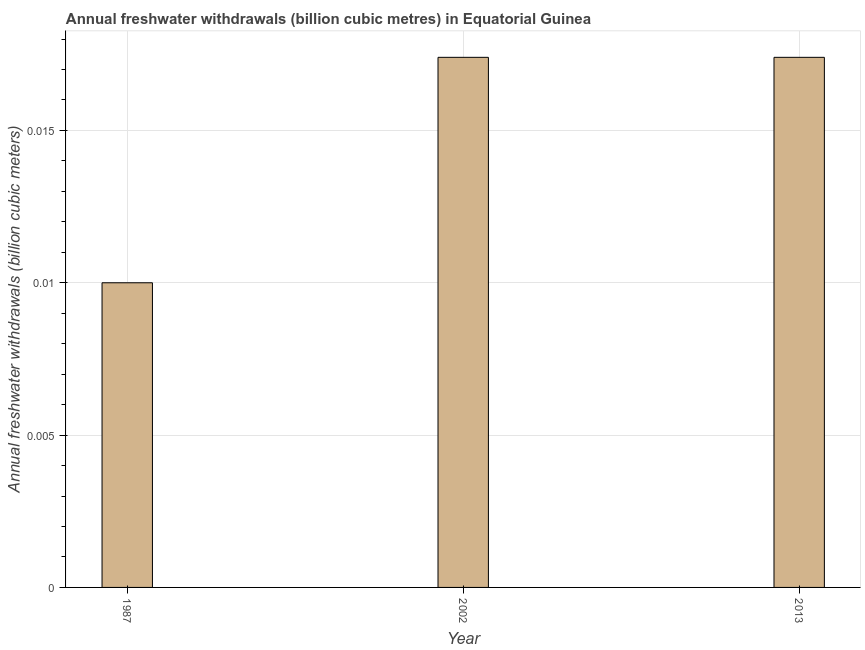What is the title of the graph?
Offer a very short reply. Annual freshwater withdrawals (billion cubic metres) in Equatorial Guinea. What is the label or title of the X-axis?
Provide a short and direct response. Year. What is the label or title of the Y-axis?
Your response must be concise. Annual freshwater withdrawals (billion cubic meters). What is the annual freshwater withdrawals in 2013?
Keep it short and to the point. 0.02. Across all years, what is the maximum annual freshwater withdrawals?
Your answer should be very brief. 0.02. Across all years, what is the minimum annual freshwater withdrawals?
Your response must be concise. 0.01. What is the sum of the annual freshwater withdrawals?
Offer a terse response. 0.04. What is the difference between the annual freshwater withdrawals in 1987 and 2013?
Ensure brevity in your answer.  -0.01. What is the average annual freshwater withdrawals per year?
Offer a very short reply. 0.01. What is the median annual freshwater withdrawals?
Provide a succinct answer. 0.02. In how many years, is the annual freshwater withdrawals greater than 0.013 billion cubic meters?
Your response must be concise. 2. What is the ratio of the annual freshwater withdrawals in 1987 to that in 2002?
Offer a very short reply. 0.57. Is the annual freshwater withdrawals in 2002 less than that in 2013?
Your answer should be compact. No. Is the difference between the annual freshwater withdrawals in 1987 and 2013 greater than the difference between any two years?
Your answer should be very brief. Yes. What is the difference between the highest and the second highest annual freshwater withdrawals?
Provide a short and direct response. 0. Is the sum of the annual freshwater withdrawals in 1987 and 2002 greater than the maximum annual freshwater withdrawals across all years?
Ensure brevity in your answer.  Yes. What is the difference between the highest and the lowest annual freshwater withdrawals?
Offer a very short reply. 0.01. Are all the bars in the graph horizontal?
Your answer should be compact. No. How many years are there in the graph?
Your response must be concise. 3. What is the difference between two consecutive major ticks on the Y-axis?
Your answer should be very brief. 0.01. What is the Annual freshwater withdrawals (billion cubic meters) in 2002?
Ensure brevity in your answer.  0.02. What is the Annual freshwater withdrawals (billion cubic meters) in 2013?
Provide a succinct answer. 0.02. What is the difference between the Annual freshwater withdrawals (billion cubic meters) in 1987 and 2002?
Offer a very short reply. -0.01. What is the difference between the Annual freshwater withdrawals (billion cubic meters) in 1987 and 2013?
Offer a very short reply. -0.01. What is the ratio of the Annual freshwater withdrawals (billion cubic meters) in 1987 to that in 2002?
Make the answer very short. 0.57. What is the ratio of the Annual freshwater withdrawals (billion cubic meters) in 1987 to that in 2013?
Ensure brevity in your answer.  0.57. 